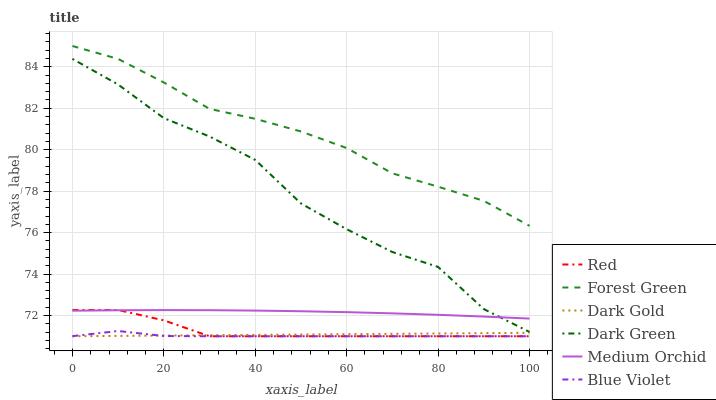Does Blue Violet have the minimum area under the curve?
Answer yes or no. Yes. Does Forest Green have the maximum area under the curve?
Answer yes or no. Yes. Does Medium Orchid have the minimum area under the curve?
Answer yes or no. No. Does Medium Orchid have the maximum area under the curve?
Answer yes or no. No. Is Dark Gold the smoothest?
Answer yes or no. Yes. Is Dark Green the roughest?
Answer yes or no. Yes. Is Medium Orchid the smoothest?
Answer yes or no. No. Is Medium Orchid the roughest?
Answer yes or no. No. Does Medium Orchid have the lowest value?
Answer yes or no. No. Does Medium Orchid have the highest value?
Answer yes or no. No. Is Blue Violet less than Forest Green?
Answer yes or no. Yes. Is Medium Orchid greater than Dark Gold?
Answer yes or no. Yes. Does Blue Violet intersect Forest Green?
Answer yes or no. No. 